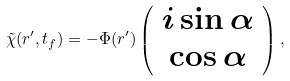<formula> <loc_0><loc_0><loc_500><loc_500>\tilde { \chi } ( r ^ { \prime } , t _ { f } ) = - \Phi ( r ^ { \prime } ) \left ( \begin{array} { c } i \sin \alpha \\ \cos \alpha \end{array} \right ) ,</formula> 